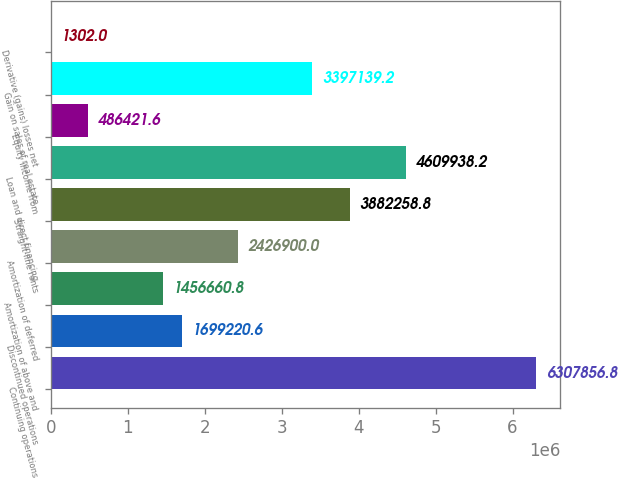Convert chart. <chart><loc_0><loc_0><loc_500><loc_500><bar_chart><fcel>Continuing operations<fcel>Discontinued operations<fcel>Amortization of above and<fcel>Amortization of deferred<fcel>Straight-line rents<fcel>Loan and direct financing<fcel>Equity income from<fcel>Gain on sales of real estate<fcel>Derivative (gains) losses net<nl><fcel>6.30786e+06<fcel>1.69922e+06<fcel>1.45666e+06<fcel>2.4269e+06<fcel>3.88226e+06<fcel>4.60994e+06<fcel>486422<fcel>3.39714e+06<fcel>1302<nl></chart> 